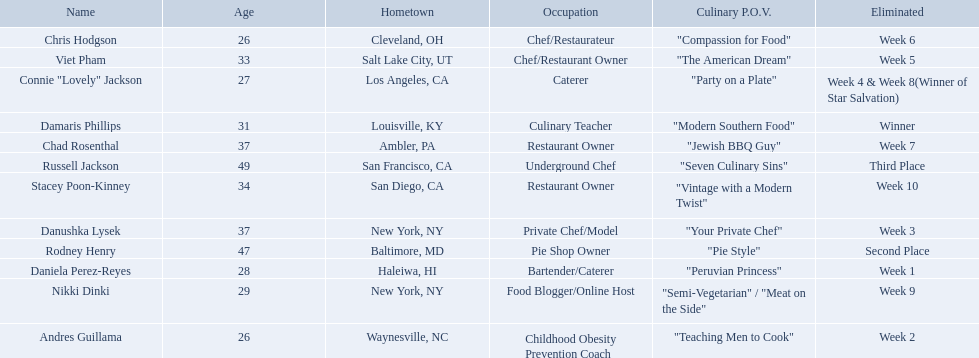Who where the people in the food network? Damaris Phillips, Rodney Henry, Russell Jackson, Stacey Poon-Kinney, Nikki Dinki, Chad Rosenthal, Chris Hodgson, Viet Pham, Connie "Lovely" Jackson, Danushka Lysek, Andres Guillama, Daniela Perez-Reyes. When was nikki dinki eliminated? Week 9. When was viet pham eliminated? Week 5. Which of these two is earlier? Week 5. Who was eliminated in this week? Viet Pham. Who are all of the people listed? Damaris Phillips, Rodney Henry, Russell Jackson, Stacey Poon-Kinney, Nikki Dinki, Chad Rosenthal, Chris Hodgson, Viet Pham, Connie "Lovely" Jackson, Danushka Lysek, Andres Guillama, Daniela Perez-Reyes. How old are they? 31, 47, 49, 34, 29, 37, 26, 33, 27, 37, 26, 28. Along with chris hodgson, which other person is 26 years old? Andres Guillama. Which food network star contestants are in their 20s? Nikki Dinki, Chris Hodgson, Connie "Lovely" Jackson, Andres Guillama, Daniela Perez-Reyes. Of these contestants, which one is the same age as chris hodgson? Andres Guillama. 